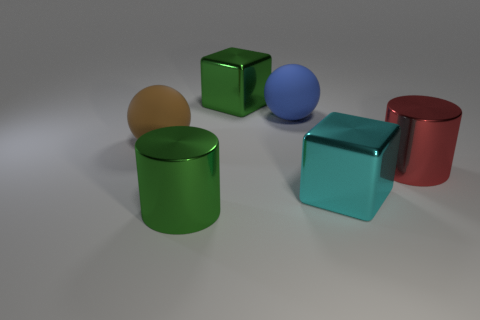Subtract 1 balls. How many balls are left? 1 Add 2 small cyan metallic balls. How many objects exist? 8 Subtract all balls. How many objects are left? 4 Subtract 0 blue blocks. How many objects are left? 6 Subtract all gray spheres. Subtract all blue cylinders. How many spheres are left? 2 Subtract all yellow balls. How many green cylinders are left? 1 Subtract all blue balls. Subtract all small objects. How many objects are left? 5 Add 6 brown matte things. How many brown matte things are left? 7 Add 1 tiny cyan objects. How many tiny cyan objects exist? 1 